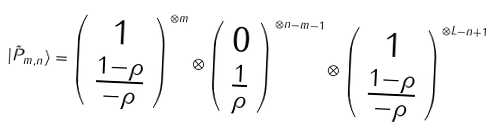Convert formula to latex. <formula><loc_0><loc_0><loc_500><loc_500>| \tilde { P } _ { m , n } \rangle = \left ( \begin{array} { c } 1 \\ \frac { 1 - \rho } { - \rho } \end{array} \right ) ^ { \otimes m } \otimes \left ( \begin{array} { c } 0 \\ \frac { 1 } { \rho } \end{array} \right ) ^ { \otimes n - m - 1 } \otimes \left ( \begin{array} { c } 1 \\ \frac { 1 - \rho } { - \rho } \end{array} \right ) ^ { \otimes L - n + 1 }</formula> 